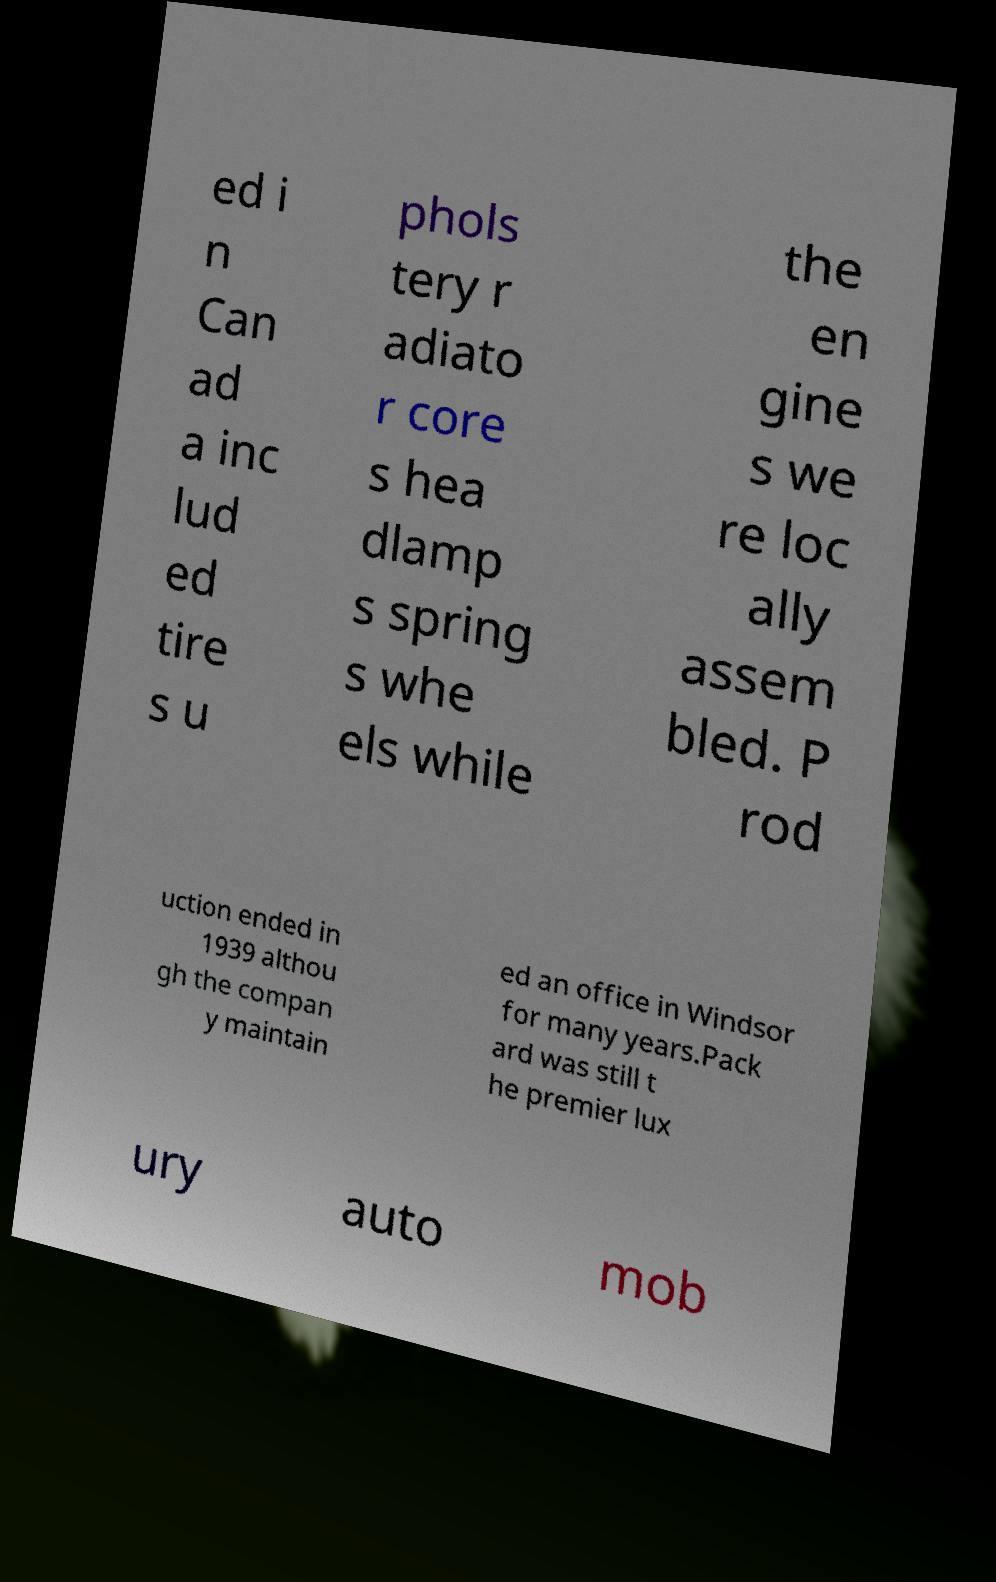Can you accurately transcribe the text from the provided image for me? ed i n Can ad a inc lud ed tire s u phols tery r adiato r core s hea dlamp s spring s whe els while the en gine s we re loc ally assem bled. P rod uction ended in 1939 althou gh the compan y maintain ed an office in Windsor for many years.Pack ard was still t he premier lux ury auto mob 